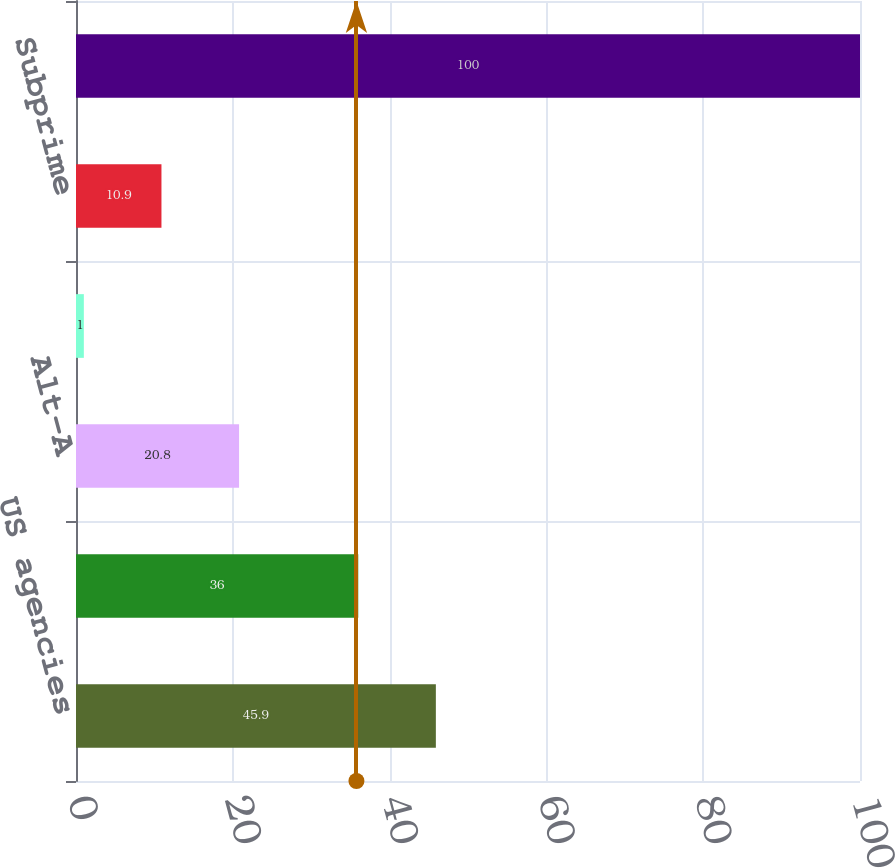<chart> <loc_0><loc_0><loc_500><loc_500><bar_chart><fcel>US agencies<fcel>Prime non-agency (a)<fcel>Alt-A<fcel>Other housing-related (b)<fcel>Subprime<fcel>Total<nl><fcel>45.9<fcel>36<fcel>20.8<fcel>1<fcel>10.9<fcel>100<nl></chart> 